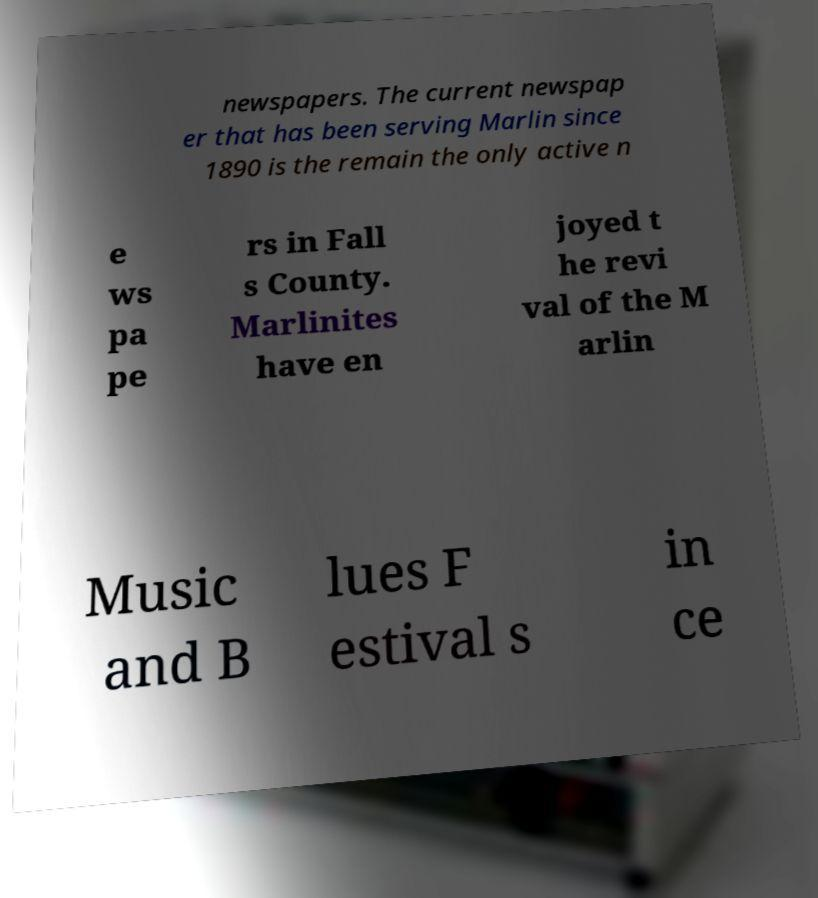Could you assist in decoding the text presented in this image and type it out clearly? newspapers. The current newspap er that has been serving Marlin since 1890 is the remain the only active n e ws pa pe rs in Fall s County. Marlinites have en joyed t he revi val of the M arlin Music and B lues F estival s in ce 